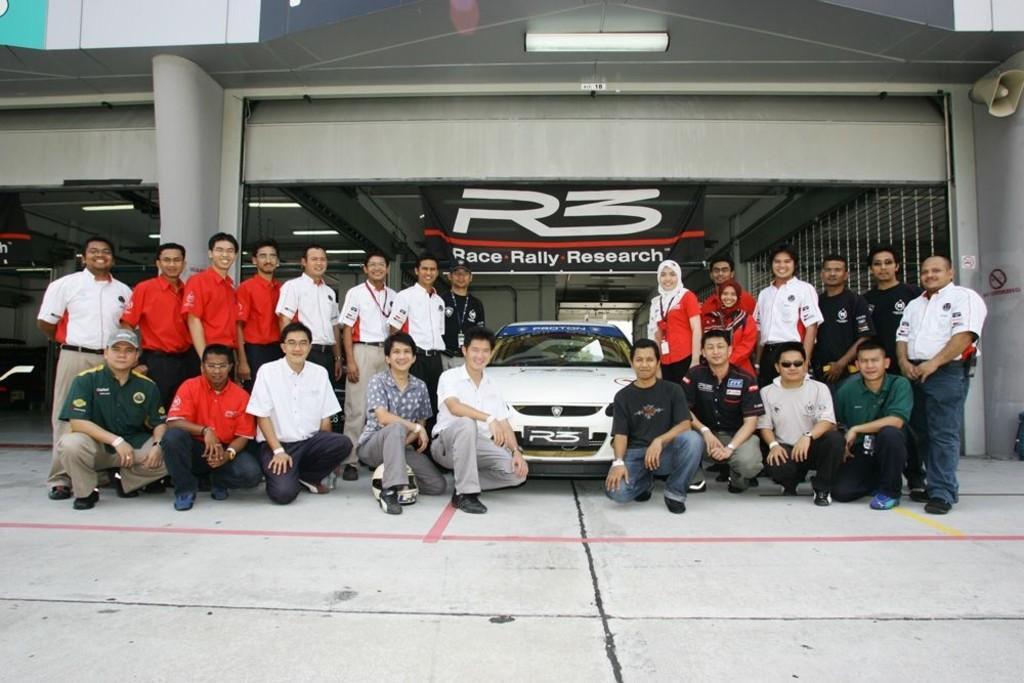In one or two sentences, can you explain what this image depicts? In this image I see number of people in which few of them are sitting and rest of them are standing and I see a car over here which is of white in color and I see that most of them are smiling and I see something is written over here and I see the path. In the background I see the lights on the ceiling. 